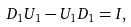Convert formula to latex. <formula><loc_0><loc_0><loc_500><loc_500>D _ { 1 } U _ { 1 } - U _ { 1 } D _ { 1 } = I ,</formula> 